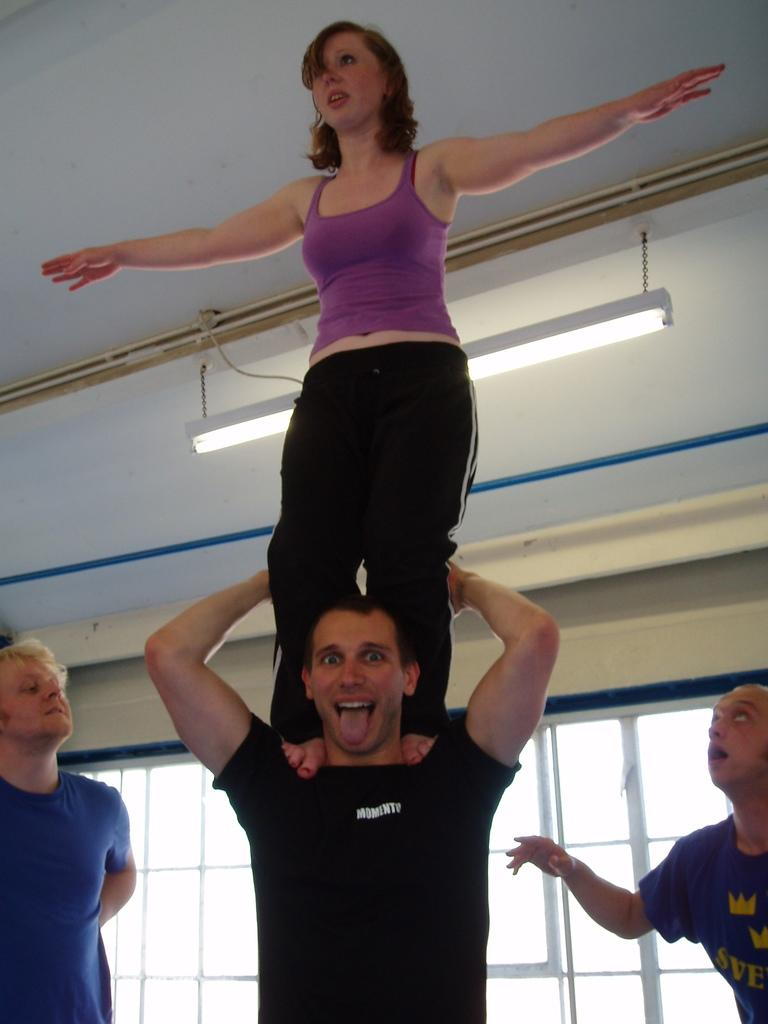What is the man in the image doing with the woman? The man is holding the woman on his shoulders. How many men are standing in the image? There are two men standing in the image. What can be seen on the ceiling in the background? There is a tube light on the ceiling in the background. What is visible in the background of the image? There are windows in the background. What type of brick is being used to construct the story in the image? There is no construction or brick visible in the image; it features a man holding a woman on his shoulders and two men standing nearby. 